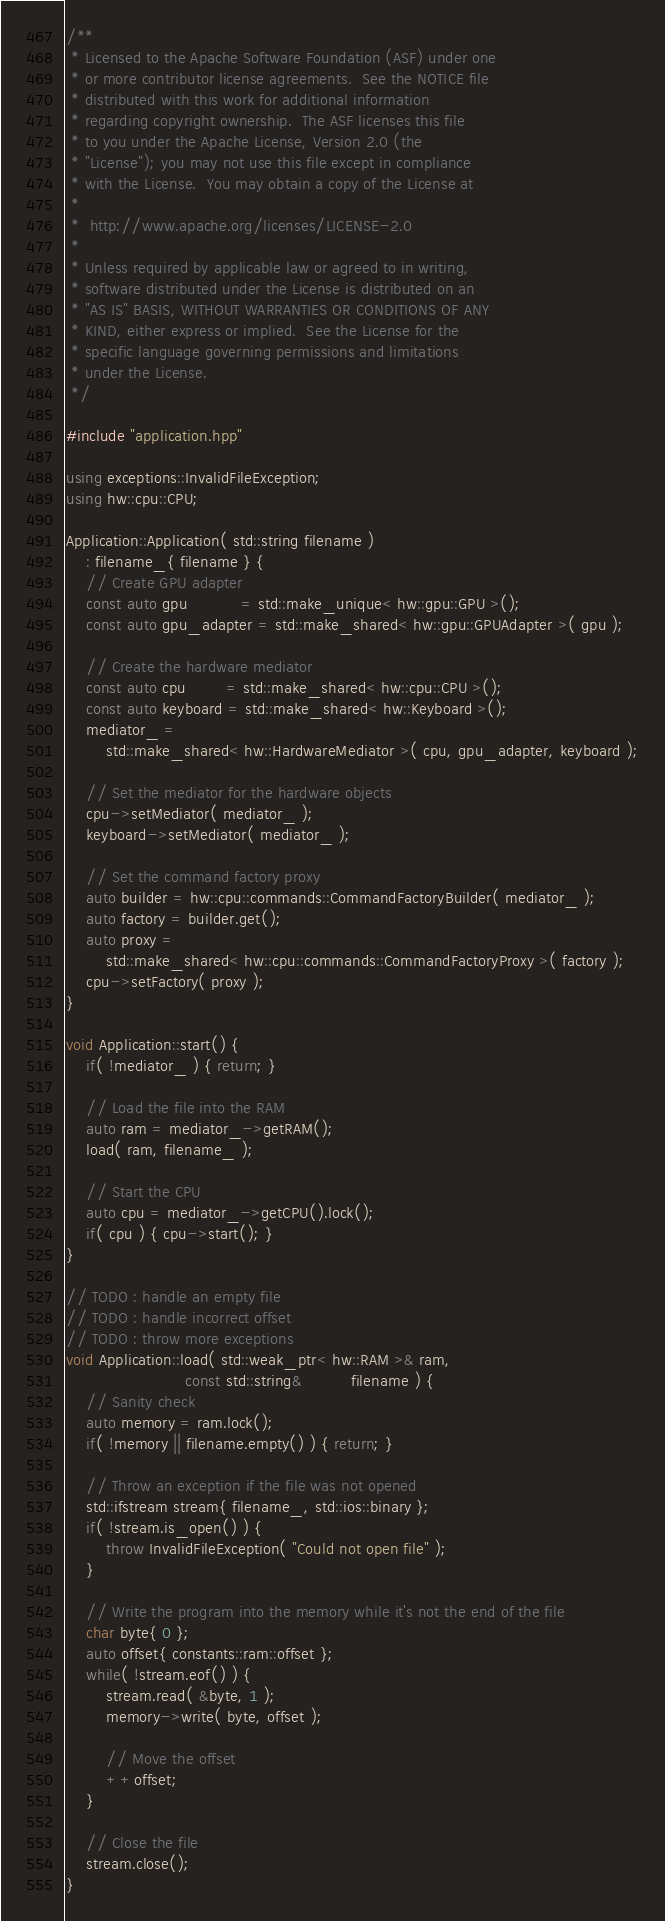Convert code to text. <code><loc_0><loc_0><loc_500><loc_500><_C++_>/**
 * Licensed to the Apache Software Foundation (ASF) under one
 * or more contributor license agreements.  See the NOTICE file
 * distributed with this work for additional information
 * regarding copyright ownership.  The ASF licenses this file
 * to you under the Apache License, Version 2.0 (the
 * "License"); you may not use this file except in compliance
 * with the License.  You may obtain a copy of the License at
 * 
 *  http://www.apache.org/licenses/LICENSE-2.0
 * 
 * Unless required by applicable law or agreed to in writing,
 * software distributed under the License is distributed on an
 * "AS IS" BASIS, WITHOUT WARRANTIES OR CONDITIONS OF ANY
 * KIND, either express or implied.  See the License for the
 * specific language governing permissions and limitations
 * under the License.
 */

#include "application.hpp"

using exceptions::InvalidFileException;
using hw::cpu::CPU;

Application::Application( std::string filename )
	: filename_{ filename } {
	// Create GPU adapter
	const auto gpu		   = std::make_unique< hw::gpu::GPU >();
	const auto gpu_adapter = std::make_shared< hw::gpu::GPUAdapter >( gpu );

	// Create the hardware mediator
	const auto cpu		= std::make_shared< hw::cpu::CPU >();
	const auto keyboard = std::make_shared< hw::Keyboard >();
	mediator_ =
		std::make_shared< hw::HardwareMediator >( cpu, gpu_adapter, keyboard );

	// Set the mediator for the hardware objects
	cpu->setMediator( mediator_ );
	keyboard->setMediator( mediator_ );

	// Set the command factory proxy
	auto builder = hw::cpu::commands::CommandFactoryBuilder( mediator_ );
	auto factory = builder.get();
	auto proxy =
		std::make_shared< hw::cpu::commands::CommandFactoryProxy >( factory );
	cpu->setFactory( proxy );
}

void Application::start() {
	if( !mediator_ ) { return; }

	// Load the file into the RAM
	auto ram = mediator_->getRAM();
	load( ram, filename_ );

	// Start the CPU
	auto cpu = mediator_->getCPU().lock();
	if( cpu ) { cpu->start(); }
}

// TODO : handle an empty file
// TODO : handle incorrect offset
// TODO : throw more exceptions
void Application::load( std::weak_ptr< hw::RAM >& ram,
						const std::string&		  filename ) {
	// Sanity check
	auto memory = ram.lock();
	if( !memory || filename.empty() ) { return; }

	// Throw an exception if the file was not opened
	std::ifstream stream{ filename_, std::ios::binary };
	if( !stream.is_open() ) {
		throw InvalidFileException( "Could not open file" );
	}

	// Write the program into the memory while it's not the end of the file
	char byte{ 0 };
	auto offset{ constants::ram::offset };
	while( !stream.eof() ) {
		stream.read( &byte, 1 );
		memory->write( byte, offset );

		// Move the offset
		++offset;
	}

	// Close the file
	stream.close();
}</code> 